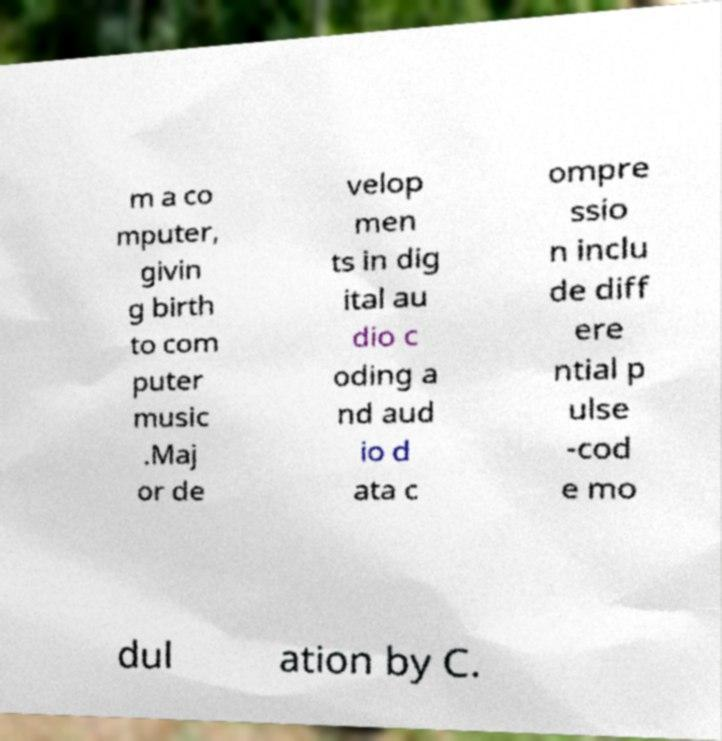What messages or text are displayed in this image? I need them in a readable, typed format. m a co mputer, givin g birth to com puter music .Maj or de velop men ts in dig ital au dio c oding a nd aud io d ata c ompre ssio n inclu de diff ere ntial p ulse -cod e mo dul ation by C. 